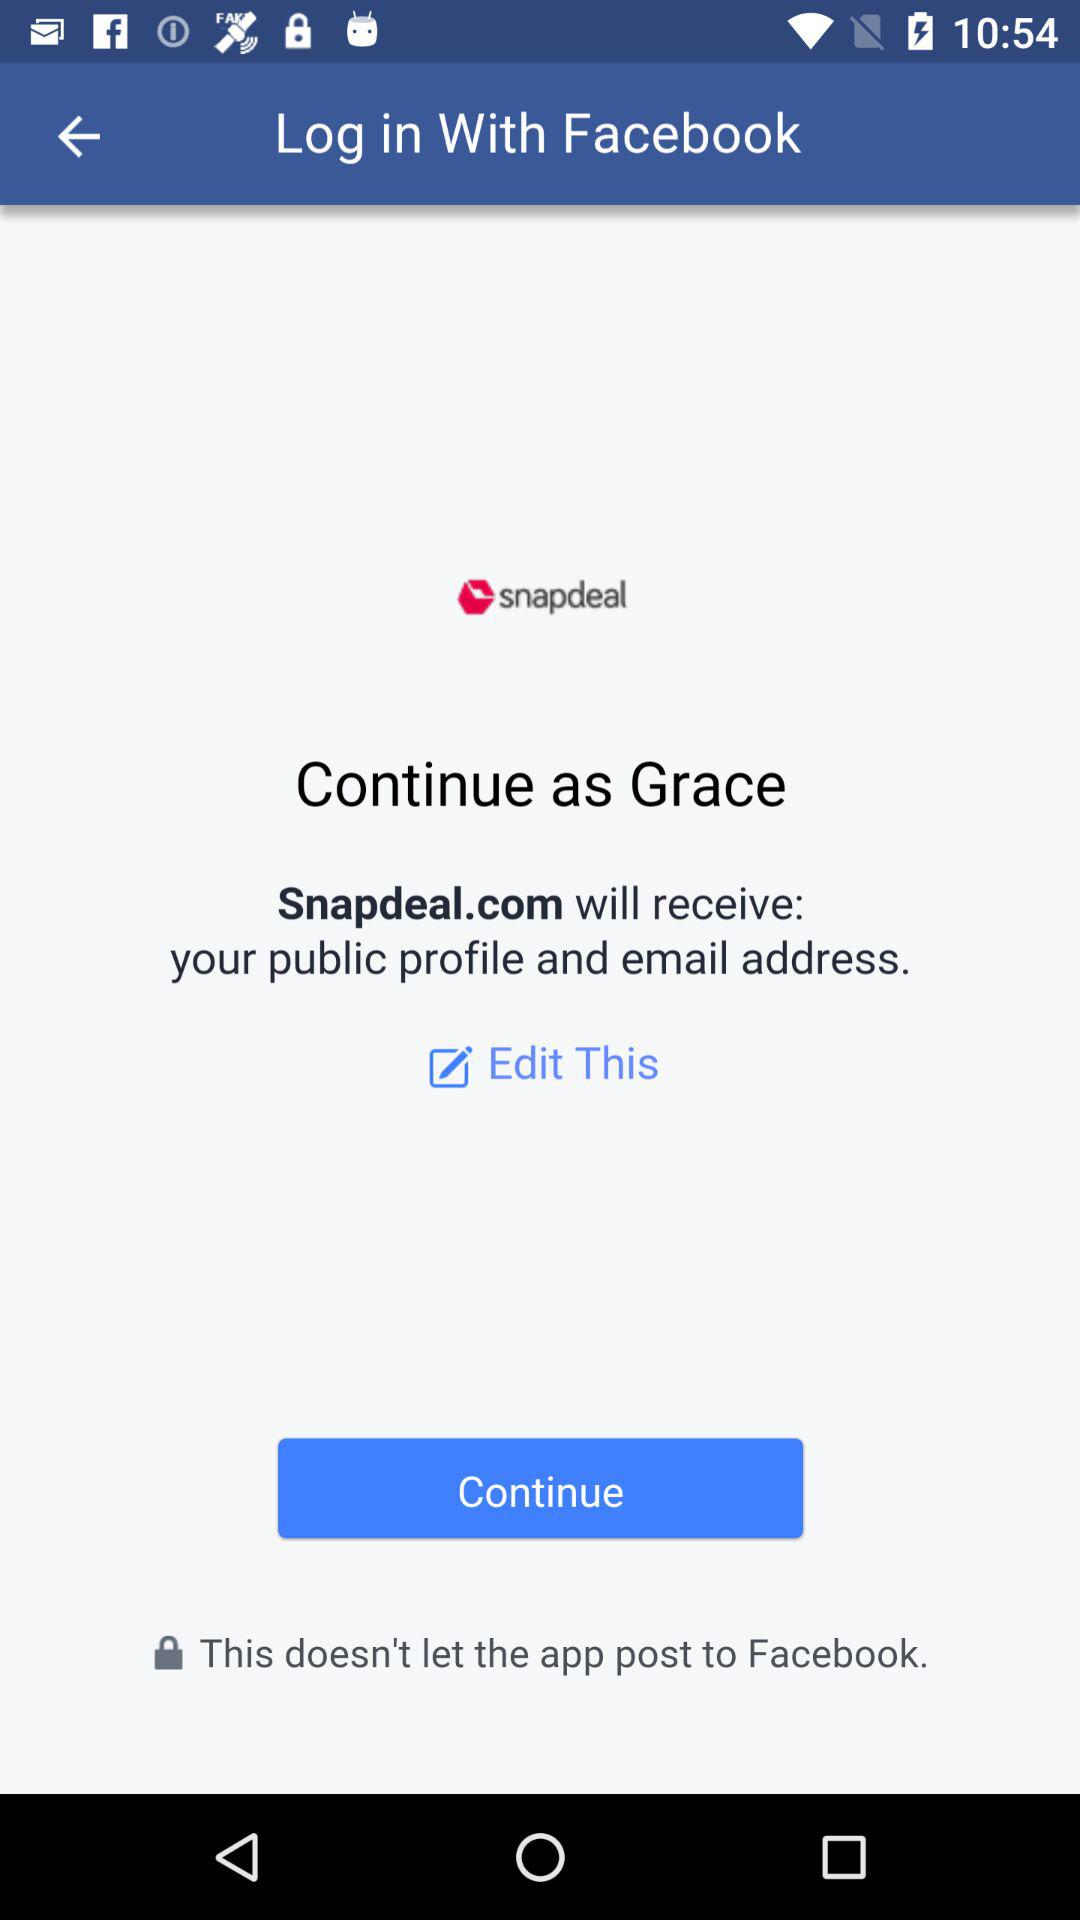What is the user name? The user name is Grace. 